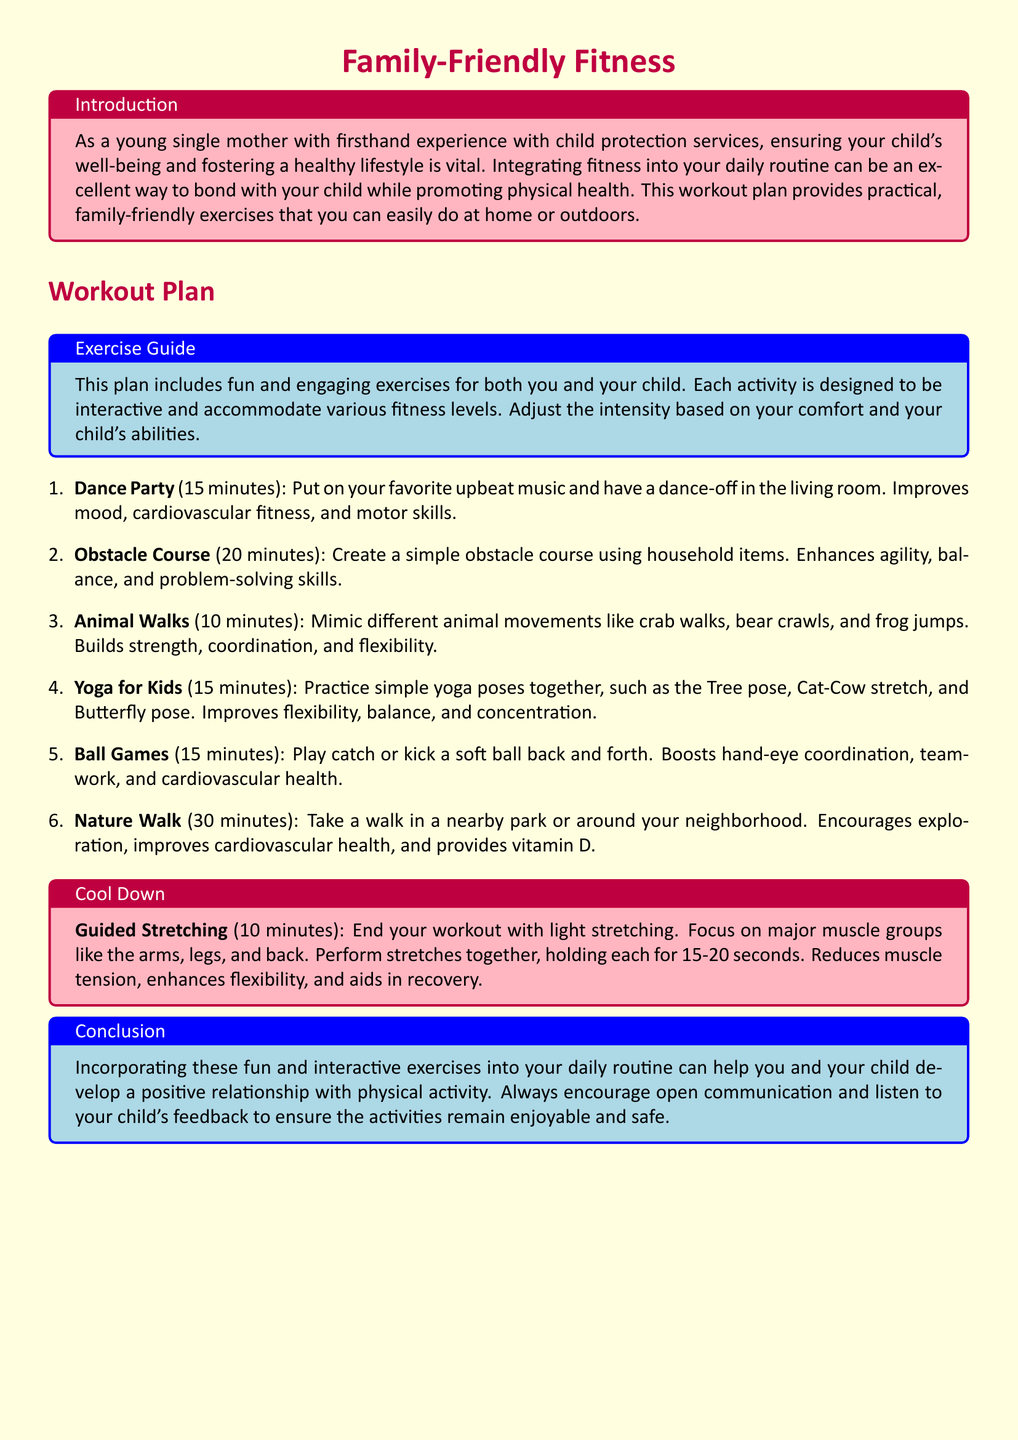What is the title of the workout plan? The title of the workout plan is presented in a highlighted format at the top of the document.
Answer: Family-Friendly Fitness How long is the Dance Party exercise? The duration for the Dance Party exercise is specified in the workout plan.
Answer: 15 minutes What cardiovascular health benefits are associated with Ball Games? The document mentions that Ball Games boost a specific health aspect as part of the exercise description.
Answer: cardiovascular health How many animal movements are suggested in the Animal Walks exercise? The Animal Walks exercise describes mimicking different animal movements but does not specify a number.
Answer: three Which exercise involves using household items? The exercise that uses household items to create a course is detailed in the workout plan.
Answer: Obstacle Course What is the purpose of the Cool Down section? The Cool Down section is designed to summarize the concluding part of the workout routine and its benefits.
Answer: Guided Stretching Which exercise is intended to improve flexibility and concentration? The document provides descriptions of exercises and their benefits, pointing out which improves flexibility and concentration.
Answer: Yoga for Kids What activity can be done outdoors for 30 minutes? The document outlines the activities along with their durations and suggests one for outdoor exercise.
Answer: Nature Walk What does the introduction emphasize about fitness? The introduction of the document highlights the importance of fitness in relation to child well-being.
Answer: healthy lifestyle 